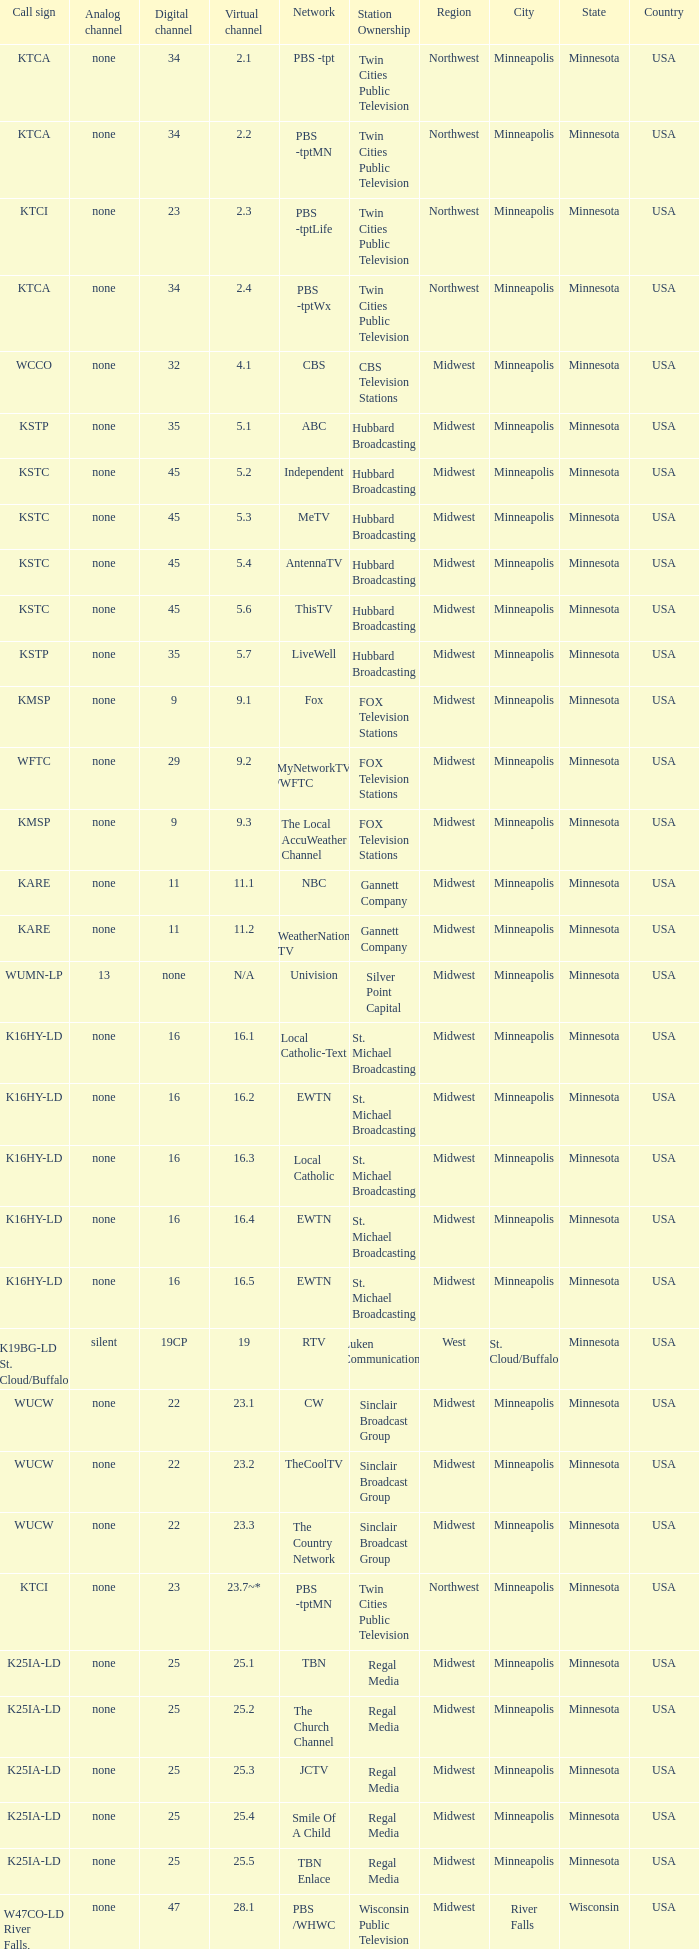Digital channel of 32 belongs to what analog channel? None. 